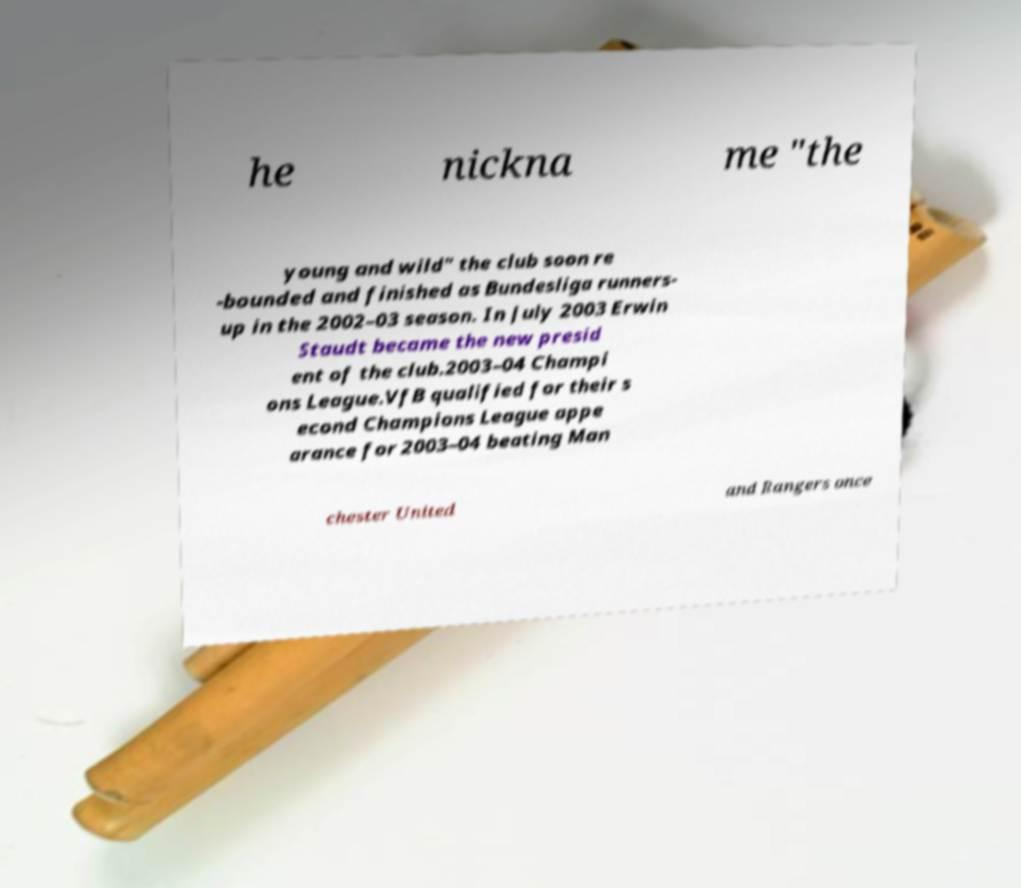There's text embedded in this image that I need extracted. Can you transcribe it verbatim? he nickna me "the young and wild" the club soon re -bounded and finished as Bundesliga runners- up in the 2002–03 season. In July 2003 Erwin Staudt became the new presid ent of the club.2003–04 Champi ons League.VfB qualified for their s econd Champions League appe arance for 2003–04 beating Man chester United and Rangers once 